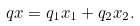Convert formula to latex. <formula><loc_0><loc_0><loc_500><loc_500>q x = q _ { 1 } x _ { 1 } + q _ { 2 } x _ { 2 } .</formula> 